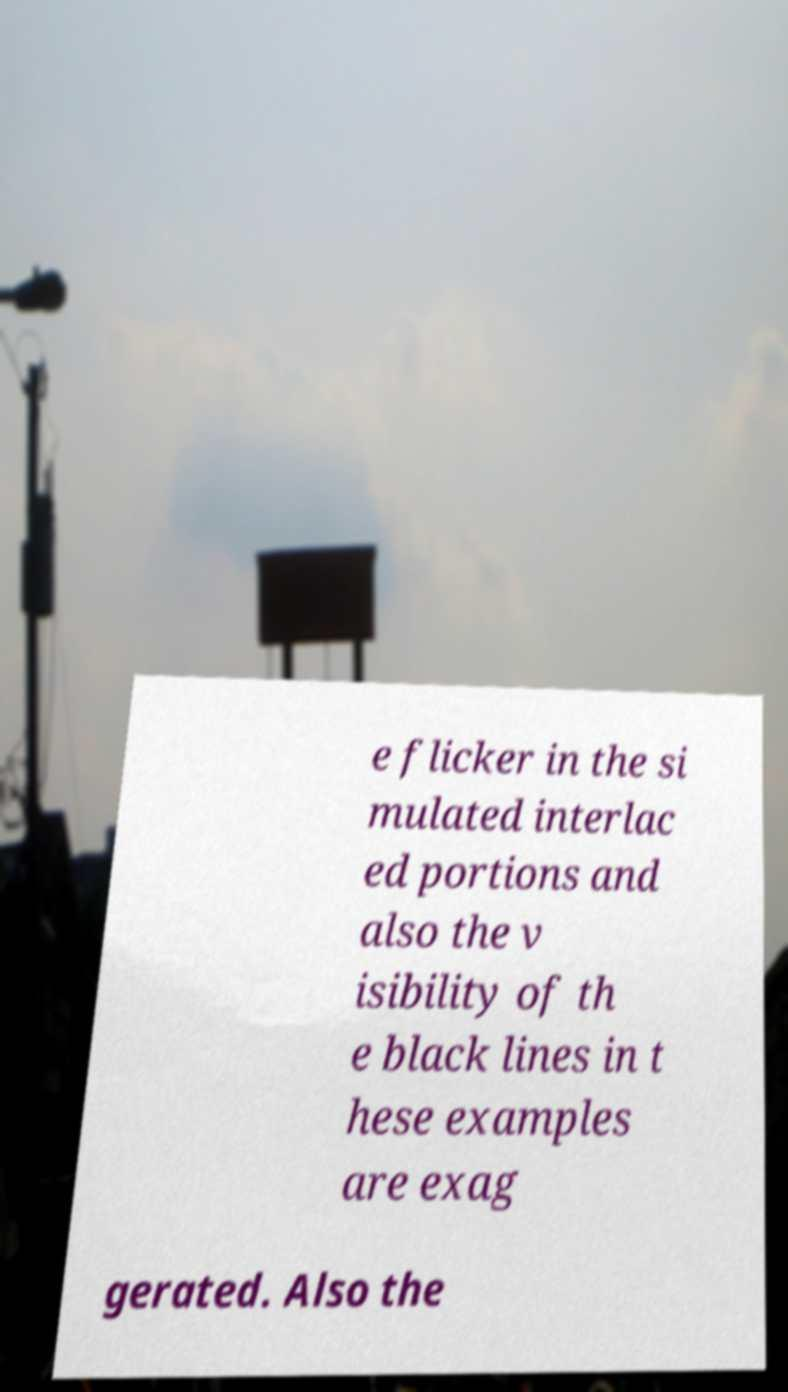Could you extract and type out the text from this image? e flicker in the si mulated interlac ed portions and also the v isibility of th e black lines in t hese examples are exag gerated. Also the 